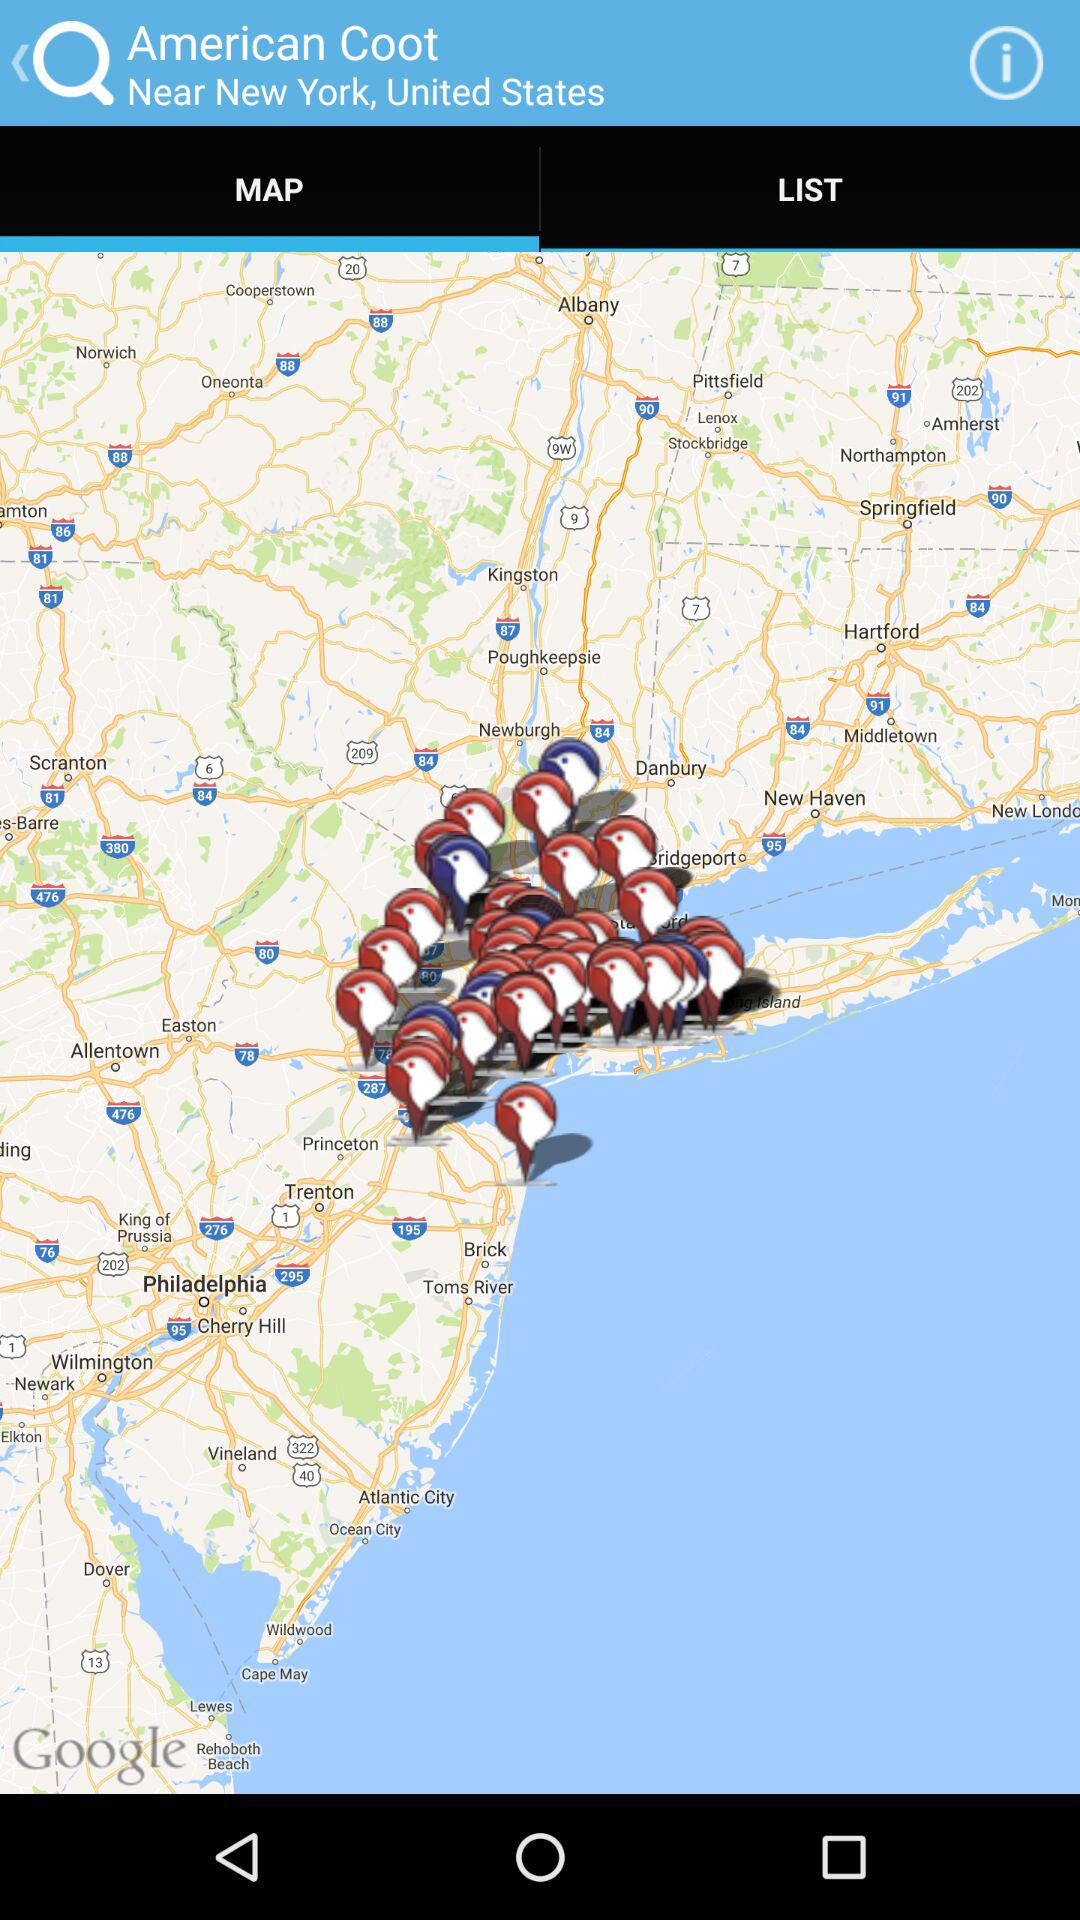Which tab is selected? The selected tab is "MAP". 